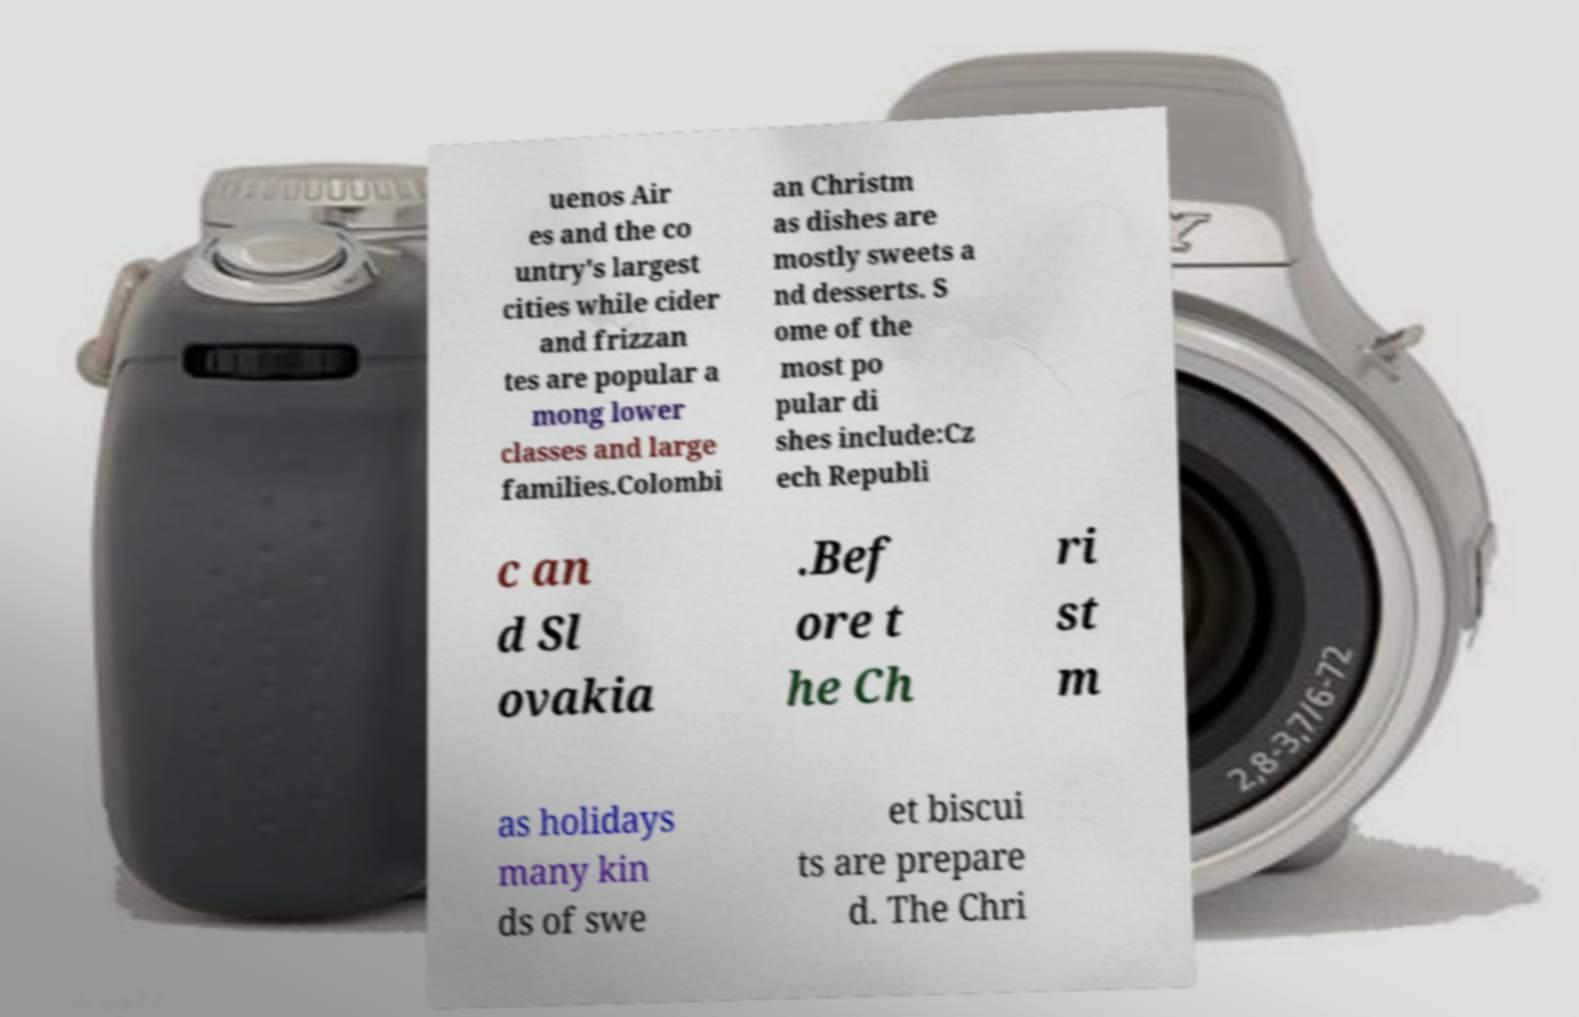For documentation purposes, I need the text within this image transcribed. Could you provide that? uenos Air es and the co untry's largest cities while cider and frizzan tes are popular a mong lower classes and large families.Colombi an Christm as dishes are mostly sweets a nd desserts. S ome of the most po pular di shes include:Cz ech Republi c an d Sl ovakia .Bef ore t he Ch ri st m as holidays many kin ds of swe et biscui ts are prepare d. The Chri 